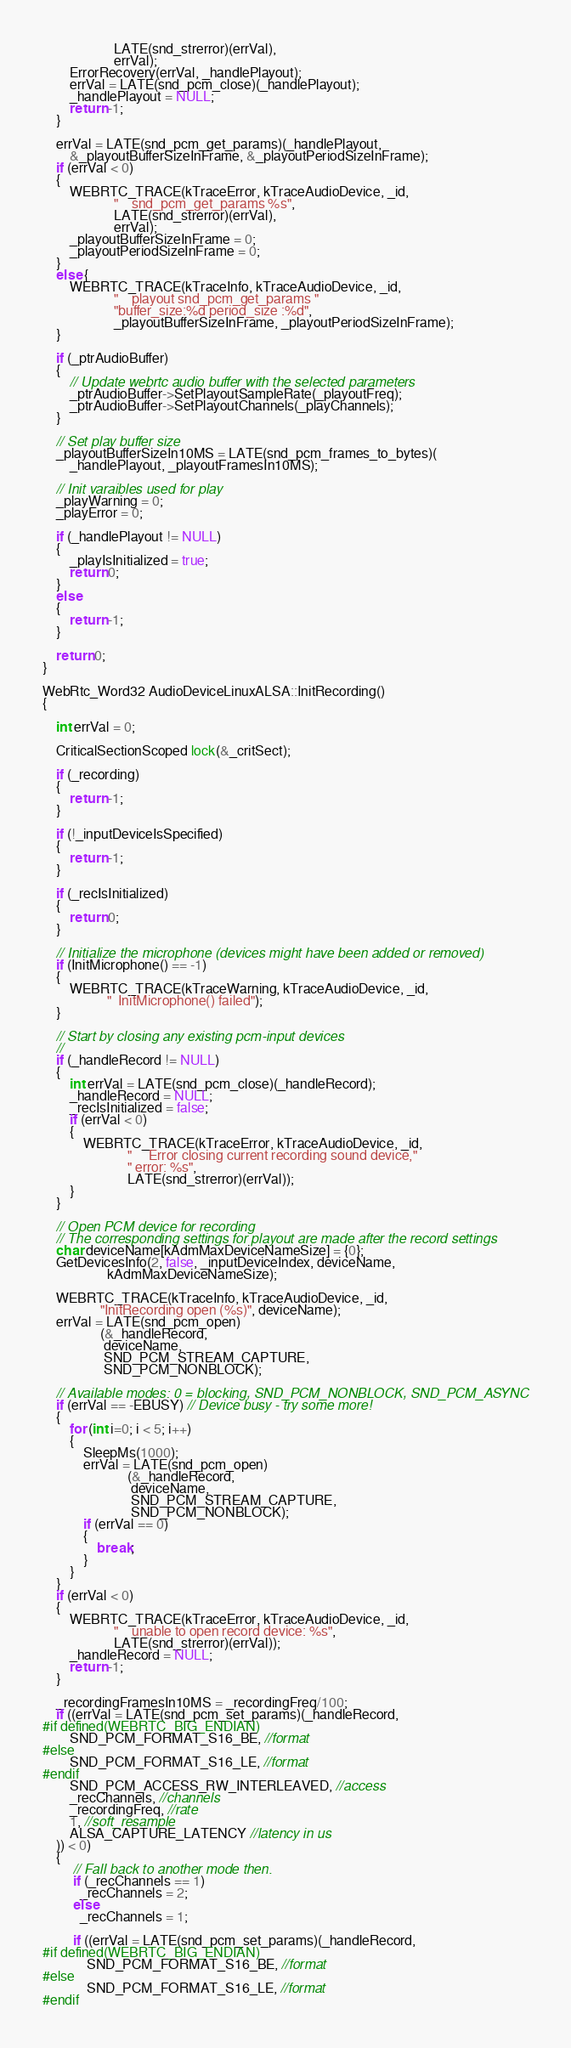Convert code to text. <code><loc_0><loc_0><loc_500><loc_500><_C++_>                     LATE(snd_strerror)(errVal),
                     errVal);
        ErrorRecovery(errVal, _handlePlayout);
        errVal = LATE(snd_pcm_close)(_handlePlayout);
        _handlePlayout = NULL;
        return -1;
    }

    errVal = LATE(snd_pcm_get_params)(_handlePlayout,
        &_playoutBufferSizeInFrame, &_playoutPeriodSizeInFrame);
    if (errVal < 0)
    {
        WEBRTC_TRACE(kTraceError, kTraceAudioDevice, _id,
                     "    snd_pcm_get_params %s",
                     LATE(snd_strerror)(errVal),
                     errVal);
        _playoutBufferSizeInFrame = 0;
        _playoutPeriodSizeInFrame = 0;
    }
    else {
        WEBRTC_TRACE(kTraceInfo, kTraceAudioDevice, _id,
                     "    playout snd_pcm_get_params "
                     "buffer_size:%d period_size :%d",
                     _playoutBufferSizeInFrame, _playoutPeriodSizeInFrame);
    }

    if (_ptrAudioBuffer)
    {
        // Update webrtc audio buffer with the selected parameters
        _ptrAudioBuffer->SetPlayoutSampleRate(_playoutFreq);
        _ptrAudioBuffer->SetPlayoutChannels(_playChannels);
    }

    // Set play buffer size
    _playoutBufferSizeIn10MS = LATE(snd_pcm_frames_to_bytes)(
        _handlePlayout, _playoutFramesIn10MS);

    // Init varaibles used for play
    _playWarning = 0;
    _playError = 0;

    if (_handlePlayout != NULL)
    {
        _playIsInitialized = true;
        return 0;
    }
    else
    {
        return -1;
    }

    return 0;
}

WebRtc_Word32 AudioDeviceLinuxALSA::InitRecording()
{

    int errVal = 0;

    CriticalSectionScoped lock(&_critSect);

    if (_recording)
    {
        return -1;
    }

    if (!_inputDeviceIsSpecified)
    {
        return -1;
    }

    if (_recIsInitialized)
    {
        return 0;
    }

    // Initialize the microphone (devices might have been added or removed)
    if (InitMicrophone() == -1)
    {
        WEBRTC_TRACE(kTraceWarning, kTraceAudioDevice, _id,
                   "  InitMicrophone() failed");
    }

    // Start by closing any existing pcm-input devices
    //
    if (_handleRecord != NULL)
    {
        int errVal = LATE(snd_pcm_close)(_handleRecord);
        _handleRecord = NULL;
        _recIsInitialized = false;
        if (errVal < 0)
        {
            WEBRTC_TRACE(kTraceError, kTraceAudioDevice, _id,
                         "     Error closing current recording sound device,"
                         " error: %s",
                         LATE(snd_strerror)(errVal));
        }
    }

    // Open PCM device for recording
    // The corresponding settings for playout are made after the record settings
    char deviceName[kAdmMaxDeviceNameSize] = {0};
    GetDevicesInfo(2, false, _inputDeviceIndex, deviceName,
                   kAdmMaxDeviceNameSize);

    WEBRTC_TRACE(kTraceInfo, kTraceAudioDevice, _id,
                 "InitRecording open (%s)", deviceName);
    errVal = LATE(snd_pcm_open)
                 (&_handleRecord,
                  deviceName,
                  SND_PCM_STREAM_CAPTURE,
                  SND_PCM_NONBLOCK);

    // Available modes: 0 = blocking, SND_PCM_NONBLOCK, SND_PCM_ASYNC
    if (errVal == -EBUSY) // Device busy - try some more!
    {
        for (int i=0; i < 5; i++)
        {
            SleepMs(1000);
            errVal = LATE(snd_pcm_open)
                         (&_handleRecord,
                          deviceName,
                          SND_PCM_STREAM_CAPTURE,
                          SND_PCM_NONBLOCK);
            if (errVal == 0)
            {
                break;
            }
        }
    }
    if (errVal < 0)
    {
        WEBRTC_TRACE(kTraceError, kTraceAudioDevice, _id,
                     "    unable to open record device: %s",
                     LATE(snd_strerror)(errVal));
        _handleRecord = NULL;
        return -1;
    }

    _recordingFramesIn10MS = _recordingFreq/100;
    if ((errVal = LATE(snd_pcm_set_params)(_handleRecord,
#if defined(WEBRTC_BIG_ENDIAN)
        SND_PCM_FORMAT_S16_BE, //format
#else
        SND_PCM_FORMAT_S16_LE, //format
#endif
        SND_PCM_ACCESS_RW_INTERLEAVED, //access
        _recChannels, //channels
        _recordingFreq, //rate
        1, //soft_resample
        ALSA_CAPTURE_LATENCY //latency in us
    )) < 0)
    {
         // Fall back to another mode then.
         if (_recChannels == 1)
           _recChannels = 2;
         else
           _recChannels = 1;

         if ((errVal = LATE(snd_pcm_set_params)(_handleRecord,
#if defined(WEBRTC_BIG_ENDIAN)
             SND_PCM_FORMAT_S16_BE, //format
#else
             SND_PCM_FORMAT_S16_LE, //format
#endif</code> 